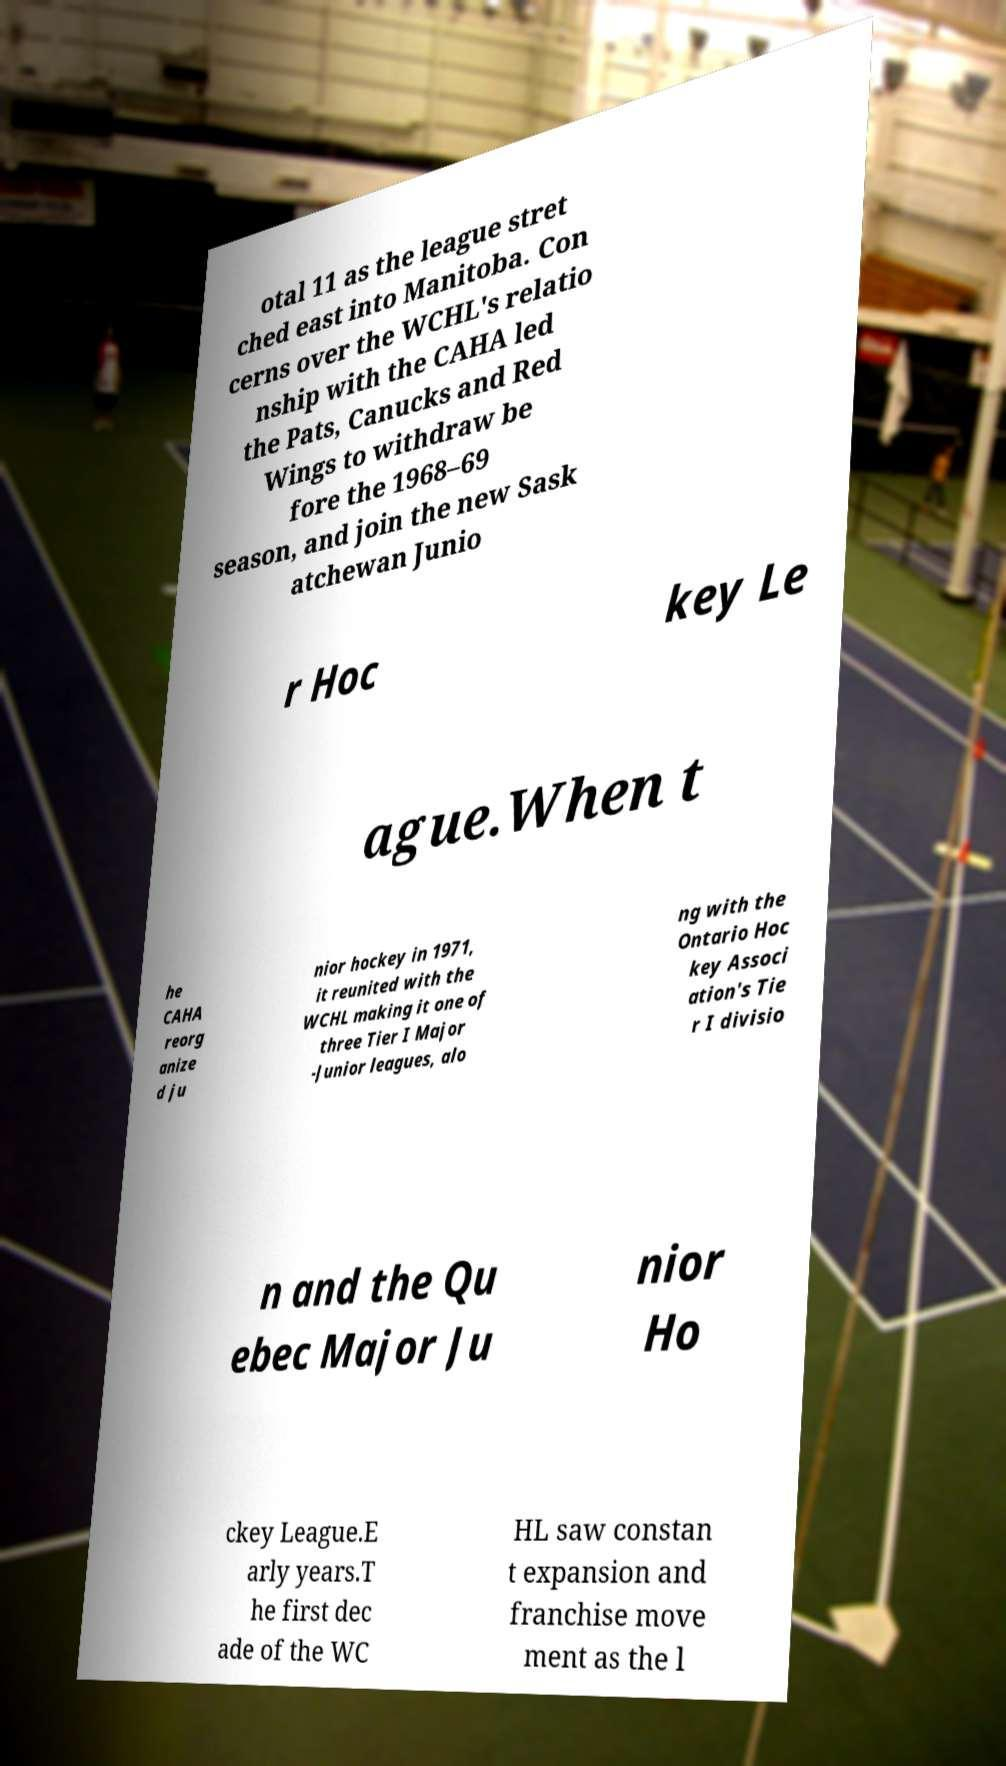Could you assist in decoding the text presented in this image and type it out clearly? otal 11 as the league stret ched east into Manitoba. Con cerns over the WCHL's relatio nship with the CAHA led the Pats, Canucks and Red Wings to withdraw be fore the 1968–69 season, and join the new Sask atchewan Junio r Hoc key Le ague.When t he CAHA reorg anize d ju nior hockey in 1971, it reunited with the WCHL making it one of three Tier I Major -Junior leagues, alo ng with the Ontario Hoc key Associ ation's Tie r I divisio n and the Qu ebec Major Ju nior Ho ckey League.E arly years.T he first dec ade of the WC HL saw constan t expansion and franchise move ment as the l 